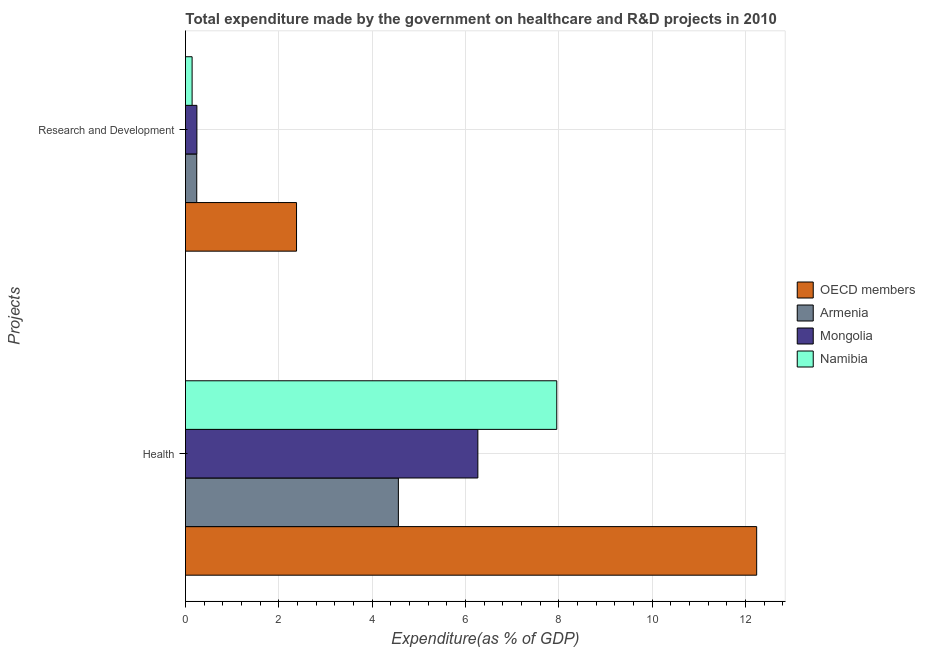How many groups of bars are there?
Offer a very short reply. 2. Are the number of bars per tick equal to the number of legend labels?
Offer a very short reply. Yes. Are the number of bars on each tick of the Y-axis equal?
Provide a short and direct response. Yes. How many bars are there on the 1st tick from the top?
Provide a short and direct response. 4. How many bars are there on the 1st tick from the bottom?
Offer a very short reply. 4. What is the label of the 1st group of bars from the top?
Make the answer very short. Research and Development. What is the expenditure in r&d in OECD members?
Your answer should be compact. 2.38. Across all countries, what is the maximum expenditure in healthcare?
Give a very brief answer. 12.24. Across all countries, what is the minimum expenditure in r&d?
Make the answer very short. 0.14. In which country was the expenditure in r&d minimum?
Make the answer very short. Namibia. What is the total expenditure in r&d in the graph?
Offer a very short reply. 3.01. What is the difference between the expenditure in healthcare in Namibia and that in Mongolia?
Provide a succinct answer. 1.69. What is the difference between the expenditure in healthcare in Mongolia and the expenditure in r&d in Namibia?
Give a very brief answer. 6.12. What is the average expenditure in healthcare per country?
Make the answer very short. 7.76. What is the difference between the expenditure in healthcare and expenditure in r&d in Armenia?
Provide a short and direct response. 4.32. What is the ratio of the expenditure in r&d in Armenia to that in OECD members?
Your response must be concise. 0.1. Is the expenditure in healthcare in OECD members less than that in Mongolia?
Offer a very short reply. No. In how many countries, is the expenditure in r&d greater than the average expenditure in r&d taken over all countries?
Your answer should be compact. 1. What does the 3rd bar from the top in Health represents?
Offer a very short reply. Armenia. What does the 3rd bar from the bottom in Research and Development represents?
Your answer should be very brief. Mongolia. How many bars are there?
Offer a very short reply. 8. Are all the bars in the graph horizontal?
Offer a very short reply. Yes. How many countries are there in the graph?
Your answer should be very brief. 4. Are the values on the major ticks of X-axis written in scientific E-notation?
Provide a short and direct response. No. Where does the legend appear in the graph?
Give a very brief answer. Center right. What is the title of the graph?
Offer a very short reply. Total expenditure made by the government on healthcare and R&D projects in 2010. What is the label or title of the X-axis?
Your response must be concise. Expenditure(as % of GDP). What is the label or title of the Y-axis?
Offer a very short reply. Projects. What is the Expenditure(as % of GDP) in OECD members in Health?
Ensure brevity in your answer.  12.24. What is the Expenditure(as % of GDP) in Armenia in Health?
Provide a short and direct response. 4.56. What is the Expenditure(as % of GDP) in Mongolia in Health?
Offer a very short reply. 6.27. What is the Expenditure(as % of GDP) in Namibia in Health?
Offer a very short reply. 7.96. What is the Expenditure(as % of GDP) in OECD members in Research and Development?
Ensure brevity in your answer.  2.38. What is the Expenditure(as % of GDP) of Armenia in Research and Development?
Your answer should be very brief. 0.24. What is the Expenditure(as % of GDP) in Mongolia in Research and Development?
Keep it short and to the point. 0.24. What is the Expenditure(as % of GDP) in Namibia in Research and Development?
Offer a very short reply. 0.14. Across all Projects, what is the maximum Expenditure(as % of GDP) in OECD members?
Offer a very short reply. 12.24. Across all Projects, what is the maximum Expenditure(as % of GDP) of Armenia?
Offer a very short reply. 4.56. Across all Projects, what is the maximum Expenditure(as % of GDP) in Mongolia?
Make the answer very short. 6.27. Across all Projects, what is the maximum Expenditure(as % of GDP) of Namibia?
Make the answer very short. 7.96. Across all Projects, what is the minimum Expenditure(as % of GDP) of OECD members?
Provide a succinct answer. 2.38. Across all Projects, what is the minimum Expenditure(as % of GDP) in Armenia?
Provide a succinct answer. 0.24. Across all Projects, what is the minimum Expenditure(as % of GDP) of Mongolia?
Ensure brevity in your answer.  0.24. Across all Projects, what is the minimum Expenditure(as % of GDP) in Namibia?
Provide a short and direct response. 0.14. What is the total Expenditure(as % of GDP) in OECD members in the graph?
Give a very brief answer. 14.62. What is the total Expenditure(as % of GDP) of Armenia in the graph?
Ensure brevity in your answer.  4.8. What is the total Expenditure(as % of GDP) in Mongolia in the graph?
Your answer should be very brief. 6.51. What is the total Expenditure(as % of GDP) in Namibia in the graph?
Your response must be concise. 8.1. What is the difference between the Expenditure(as % of GDP) of OECD members in Health and that in Research and Development?
Provide a short and direct response. 9.86. What is the difference between the Expenditure(as % of GDP) of Armenia in Health and that in Research and Development?
Provide a succinct answer. 4.32. What is the difference between the Expenditure(as % of GDP) in Mongolia in Health and that in Research and Development?
Give a very brief answer. 6.02. What is the difference between the Expenditure(as % of GDP) of Namibia in Health and that in Research and Development?
Make the answer very short. 7.81. What is the difference between the Expenditure(as % of GDP) of OECD members in Health and the Expenditure(as % of GDP) of Armenia in Research and Development?
Keep it short and to the point. 12. What is the difference between the Expenditure(as % of GDP) in OECD members in Health and the Expenditure(as % of GDP) in Mongolia in Research and Development?
Give a very brief answer. 12. What is the difference between the Expenditure(as % of GDP) of OECD members in Health and the Expenditure(as % of GDP) of Namibia in Research and Development?
Keep it short and to the point. 12.1. What is the difference between the Expenditure(as % of GDP) in Armenia in Health and the Expenditure(as % of GDP) in Mongolia in Research and Development?
Provide a succinct answer. 4.32. What is the difference between the Expenditure(as % of GDP) of Armenia in Health and the Expenditure(as % of GDP) of Namibia in Research and Development?
Provide a succinct answer. 4.42. What is the difference between the Expenditure(as % of GDP) of Mongolia in Health and the Expenditure(as % of GDP) of Namibia in Research and Development?
Give a very brief answer. 6.12. What is the average Expenditure(as % of GDP) in OECD members per Projects?
Provide a short and direct response. 7.31. What is the average Expenditure(as % of GDP) of Armenia per Projects?
Offer a terse response. 2.4. What is the average Expenditure(as % of GDP) of Mongolia per Projects?
Ensure brevity in your answer.  3.25. What is the average Expenditure(as % of GDP) of Namibia per Projects?
Keep it short and to the point. 4.05. What is the difference between the Expenditure(as % of GDP) of OECD members and Expenditure(as % of GDP) of Armenia in Health?
Your response must be concise. 7.68. What is the difference between the Expenditure(as % of GDP) in OECD members and Expenditure(as % of GDP) in Mongolia in Health?
Your response must be concise. 5.97. What is the difference between the Expenditure(as % of GDP) in OECD members and Expenditure(as % of GDP) in Namibia in Health?
Make the answer very short. 4.28. What is the difference between the Expenditure(as % of GDP) in Armenia and Expenditure(as % of GDP) in Mongolia in Health?
Your answer should be compact. -1.7. What is the difference between the Expenditure(as % of GDP) of Armenia and Expenditure(as % of GDP) of Namibia in Health?
Offer a very short reply. -3.39. What is the difference between the Expenditure(as % of GDP) of Mongolia and Expenditure(as % of GDP) of Namibia in Health?
Your answer should be very brief. -1.69. What is the difference between the Expenditure(as % of GDP) in OECD members and Expenditure(as % of GDP) in Armenia in Research and Development?
Provide a short and direct response. 2.14. What is the difference between the Expenditure(as % of GDP) in OECD members and Expenditure(as % of GDP) in Mongolia in Research and Development?
Your answer should be compact. 2.14. What is the difference between the Expenditure(as % of GDP) in OECD members and Expenditure(as % of GDP) in Namibia in Research and Development?
Your answer should be very brief. 2.24. What is the difference between the Expenditure(as % of GDP) in Armenia and Expenditure(as % of GDP) in Mongolia in Research and Development?
Make the answer very short. -0. What is the difference between the Expenditure(as % of GDP) of Armenia and Expenditure(as % of GDP) of Namibia in Research and Development?
Offer a terse response. 0.1. What is the difference between the Expenditure(as % of GDP) in Mongolia and Expenditure(as % of GDP) in Namibia in Research and Development?
Provide a short and direct response. 0.1. What is the ratio of the Expenditure(as % of GDP) of OECD members in Health to that in Research and Development?
Keep it short and to the point. 5.14. What is the ratio of the Expenditure(as % of GDP) in Mongolia in Health to that in Research and Development?
Offer a very short reply. 25.64. What is the ratio of the Expenditure(as % of GDP) in Namibia in Health to that in Research and Development?
Give a very brief answer. 56.13. What is the difference between the highest and the second highest Expenditure(as % of GDP) of OECD members?
Ensure brevity in your answer.  9.86. What is the difference between the highest and the second highest Expenditure(as % of GDP) in Armenia?
Make the answer very short. 4.32. What is the difference between the highest and the second highest Expenditure(as % of GDP) in Mongolia?
Your response must be concise. 6.02. What is the difference between the highest and the second highest Expenditure(as % of GDP) of Namibia?
Provide a succinct answer. 7.81. What is the difference between the highest and the lowest Expenditure(as % of GDP) of OECD members?
Provide a succinct answer. 9.86. What is the difference between the highest and the lowest Expenditure(as % of GDP) in Armenia?
Offer a very short reply. 4.32. What is the difference between the highest and the lowest Expenditure(as % of GDP) in Mongolia?
Your response must be concise. 6.02. What is the difference between the highest and the lowest Expenditure(as % of GDP) in Namibia?
Your answer should be compact. 7.81. 